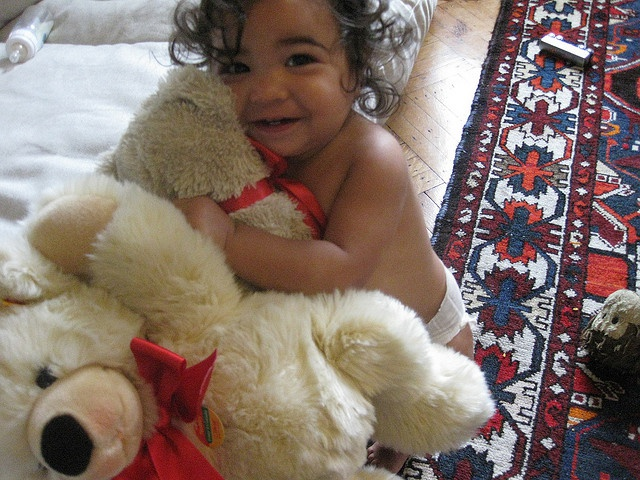Describe the objects in this image and their specific colors. I can see teddy bear in gray, tan, and darkgray tones, people in gray, brown, maroon, and black tones, bed in gray, lightgray, and darkgray tones, teddy bear in gray and maroon tones, and bottle in gray, darkgray, and lightgray tones in this image. 